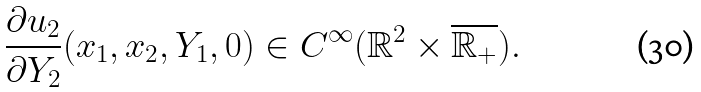Convert formula to latex. <formula><loc_0><loc_0><loc_500><loc_500>\frac { \partial u _ { 2 } } { \partial Y _ { 2 } } ( x _ { 1 } , x _ { 2 } , Y _ { 1 } , 0 ) \in C ^ { \infty } ( \mathbb { R } ^ { 2 } \times \overline { \mathbb { R } _ { + } } ) .</formula> 